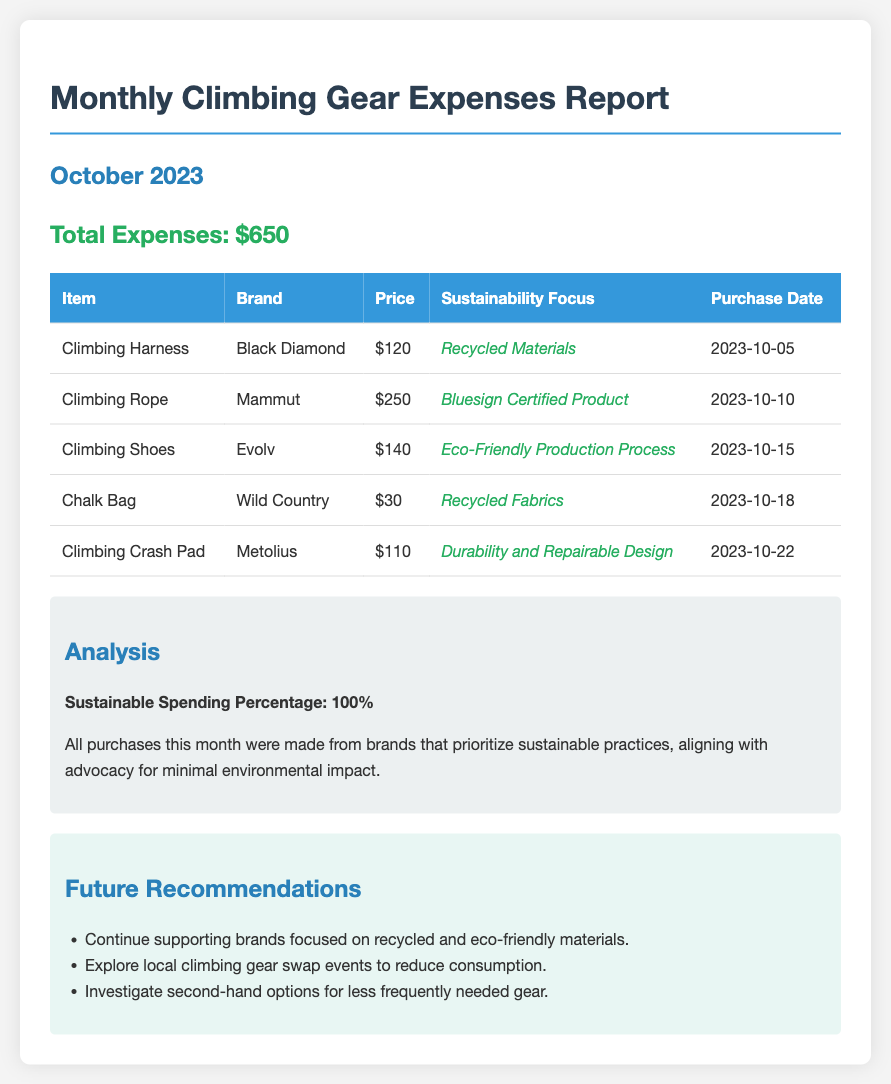what is the total expenses? The total expenses sum all the individual purchases listed in the document.
Answer: $650 what brand was the climbing harness purchased from? The specific brand of the climbing harness is mentioned in the table.
Answer: Black Diamond how much did the climbing rope cost? The cost of the climbing rope is provided in the table from the document.
Answer: $250 what is the sustainability focus of the climbing crash pad? This information is included in the sustainability focus column of the table.
Answer: Durability and Repairable Design how many items were purchased this month? The number of items can be counted from the table listings.
Answer: 5 what percentage of the spending was on sustainable brands? The document explicitly states the sustainable spending percentage.
Answer: 100% when was the climbing shoes purchased? The purchase date for the climbing shoes is listed in the table.
Answer: 2023-10-15 what is one future recommendation mentioned in the report? The recommendations section contains suggestions for future actions.
Answer: Support brands focused on recycled materials 